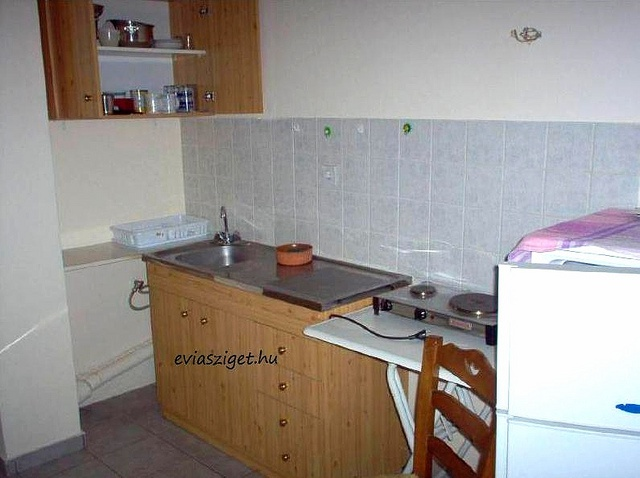Describe the objects in this image and their specific colors. I can see refrigerator in gray, white, darkgray, and lightblue tones, chair in gray, maroon, darkgray, and black tones, sink in gray, black, and darkgray tones, bowl in gray, maroon, and brown tones, and cup in gray and black tones in this image. 